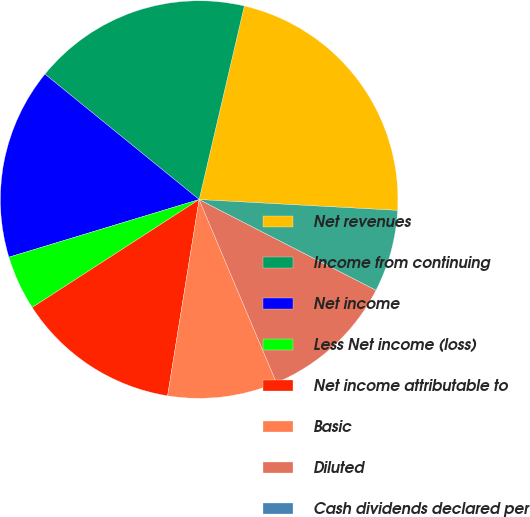Convert chart to OTSL. <chart><loc_0><loc_0><loc_500><loc_500><pie_chart><fcel>Net revenues<fcel>Income from continuing<fcel>Net income<fcel>Less Net income (loss)<fcel>Net income attributable to<fcel>Basic<fcel>Diluted<fcel>Cash dividends declared per<fcel>High<nl><fcel>22.22%<fcel>17.78%<fcel>15.55%<fcel>4.45%<fcel>13.33%<fcel>8.89%<fcel>11.11%<fcel>0.0%<fcel>6.67%<nl></chart> 